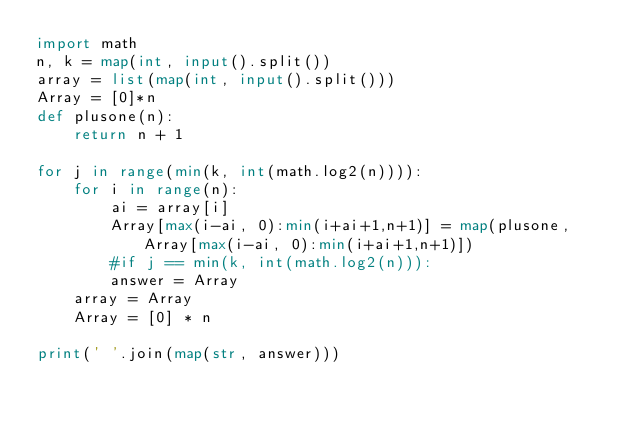Convert code to text. <code><loc_0><loc_0><loc_500><loc_500><_Python_>import math
n, k = map(int, input().split())
array = list(map(int, input().split()))
Array = [0]*n
def plusone(n):
    return n + 1

for j in range(min(k, int(math.log2(n)))):
    for i in range(n):
        ai = array[i]
        Array[max(i-ai, 0):min(i+ai+1,n+1)] = map(plusone, Array[max(i-ai, 0):min(i+ai+1,n+1)])
        #if j == min(k, int(math.log2(n))):
        answer = Array
    array = Array
    Array = [0] * n

print(' '.join(map(str, answer)))</code> 